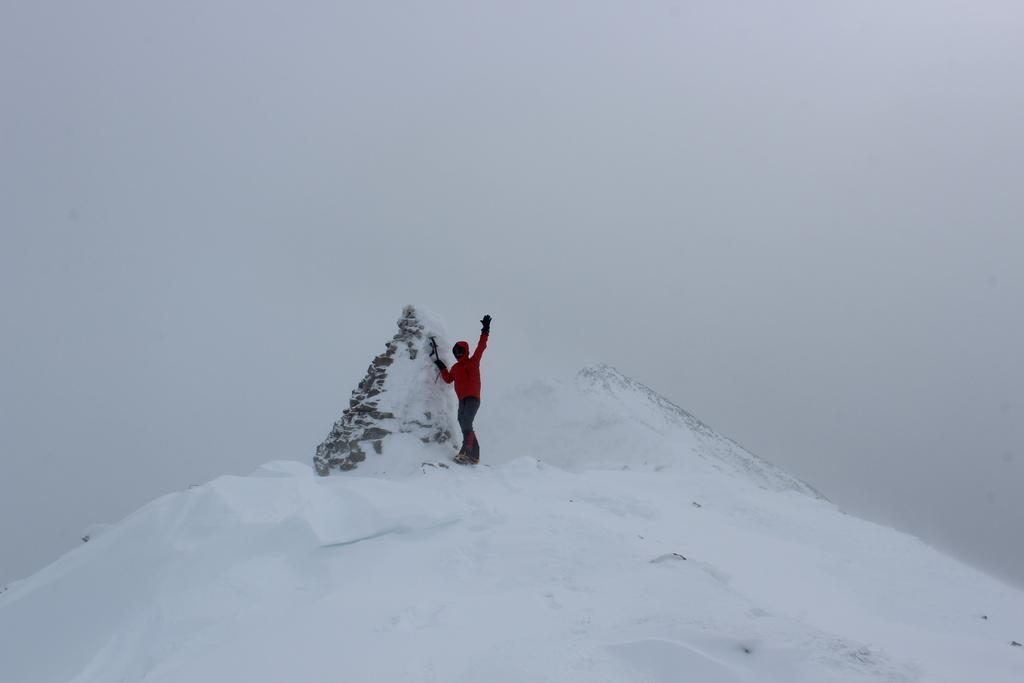In one or two sentences, can you explain what this image depicts? In this picture there is snow on the ground and there is a person standing and the sky is cloudy. 